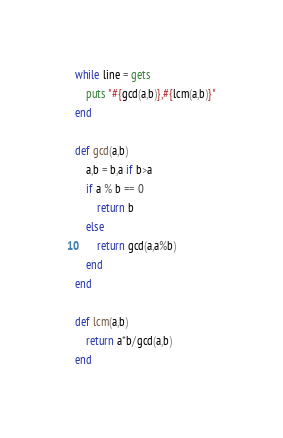Convert code to text. <code><loc_0><loc_0><loc_500><loc_500><_Ruby_>while line = gets
	puts "#{gcd(a,b)},#{lcm(a,b)}"
end

def gcd(a,b)
	a,b = b,a if b>a
	if a % b == 0
		return b
	else
		return gcd(a,a%b)
	end
end

def lcm(a,b)
	return a*b/gcd(a,b)
end</code> 